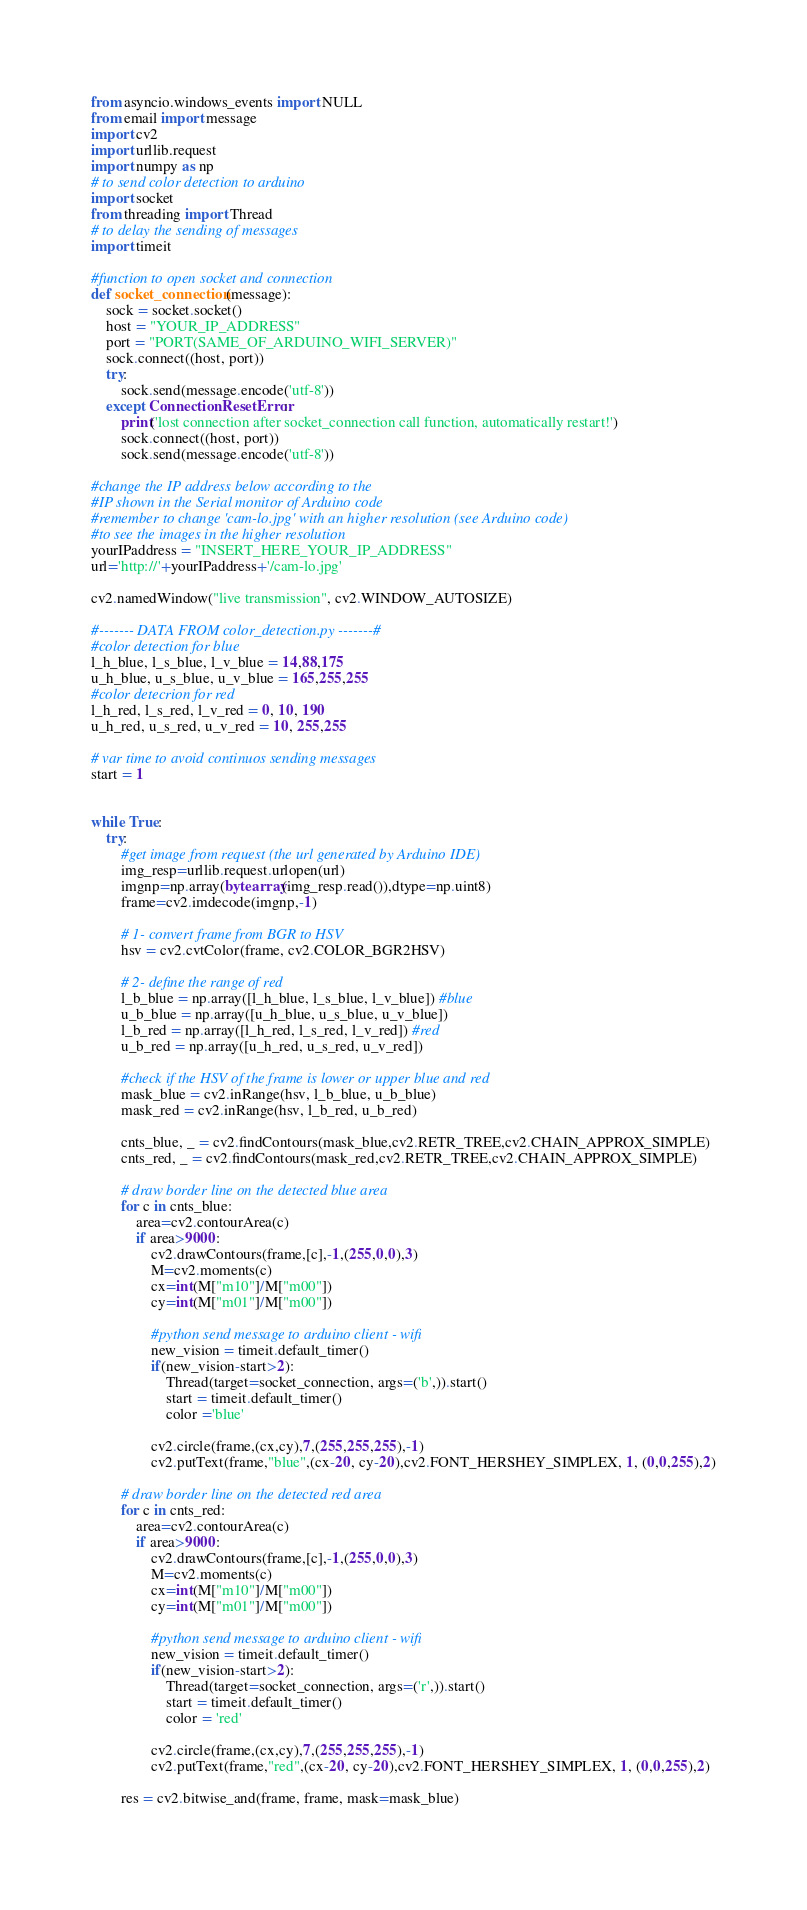<code> <loc_0><loc_0><loc_500><loc_500><_Python_>from asyncio.windows_events import NULL
from email import message
import cv2
import urllib.request
import numpy as np
# to send color detection to arduino
import socket
from threading import Thread
# to delay the sending of messages
import timeit

#function to open socket and connection
def socket_connection(message):
    sock = socket.socket()
    host = "YOUR_IP_ADDRESS" 
    port = "PORT(SAME_OF_ARDUINO_WIFI_SERVER)"                
    sock.connect((host, port))
    try: 
        sock.send(message.encode('utf-8'))
    except ConnectionResetError:
        print('lost connection after socket_connection call function, automatically restart!')
        sock.connect((host, port))
        sock.send(message.encode('utf-8'))
    
#change the IP address below according to the
#IP shown in the Serial monitor of Arduino code
#remember to change 'cam-lo.jpg' with an higher resolution (see Arduino code)
#to see the images in the higher resolution
yourIPaddress = "INSERT_HERE_YOUR_IP_ADDRESS"
url='http://'+yourIPaddress+'/cam-lo.jpg'

cv2.namedWindow("live transmission", cv2.WINDOW_AUTOSIZE)

#------- DATA FROM color_detection.py -------#
#color detection for blue
l_h_blue, l_s_blue, l_v_blue = 14,88,175
u_h_blue, u_s_blue, u_v_blue = 165,255,255
#color detecrion for red 
l_h_red, l_s_red, l_v_red = 0, 10, 190
u_h_red, u_s_red, u_v_red = 10, 255,255

# var time to avoid continuos sending messages 
start = 1


while True:
    try:
        #get image from request (the url generated by Arduino IDE)
        img_resp=urllib.request.urlopen(url)
        imgnp=np.array(bytearray(img_resp.read()),dtype=np.uint8)
        frame=cv2.imdecode(imgnp,-1)
        
        # 1- convert frame from BGR to HSV
        hsv = cv2.cvtColor(frame, cv2.COLOR_BGR2HSV)
        
        # 2- define the range of red
        l_b_blue = np.array([l_h_blue, l_s_blue, l_v_blue]) #blue
        u_b_blue = np.array([u_h_blue, u_s_blue, u_v_blue])
        l_b_red = np.array([l_h_red, l_s_red, l_v_red]) #red
        u_b_red = np.array([u_h_red, u_s_red, u_v_red])

        #check if the HSV of the frame is lower or upper blue and red
        mask_blue = cv2.inRange(hsv, l_b_blue, u_b_blue)
        mask_red = cv2.inRange(hsv, l_b_red, u_b_red)

        cnts_blue, _ = cv2.findContours(mask_blue,cv2.RETR_TREE,cv2.CHAIN_APPROX_SIMPLE)
        cnts_red, _ = cv2.findContours(mask_red,cv2.RETR_TREE,cv2.CHAIN_APPROX_SIMPLE)
    
        # draw border line on the detected blue area
        for c in cnts_blue:
            area=cv2.contourArea(c)
            if area>9000:
                cv2.drawContours(frame,[c],-1,(255,0,0),3)
                M=cv2.moments(c)
                cx=int(M["m10"]/M["m00"])
                cy=int(M["m01"]/M["m00"])

                #python send message to arduino client - wifi
                new_vision = timeit.default_timer()
                if(new_vision-start>2):
                    Thread(target=socket_connection, args=('b',)).start()
                    start = timeit.default_timer()
                    color ='blue'

                cv2.circle(frame,(cx,cy),7,(255,255,255),-1)
                cv2.putText(frame,"blue",(cx-20, cy-20),cv2.FONT_HERSHEY_SIMPLEX, 1, (0,0,255),2)
        
        # draw border line on the detected red area
        for c in cnts_red:
            area=cv2.contourArea(c)
            if area>9000:
                cv2.drawContours(frame,[c],-1,(255,0,0),3)
                M=cv2.moments(c)
                cx=int(M["m10"]/M["m00"])
                cy=int(M["m01"]/M["m00"])

                #python send message to arduino client - wifi
                new_vision = timeit.default_timer()
                if(new_vision-start>2):
                    Thread(target=socket_connection, args=('r',)).start()
                    start = timeit.default_timer()
                    color = 'red'

                cv2.circle(frame,(cx,cy),7,(255,255,255),-1)
                cv2.putText(frame,"red",(cx-20, cy-20),cv2.FONT_HERSHEY_SIMPLEX, 1, (0,0,255),2)
            
        res = cv2.bitwise_and(frame, frame, mask=mask_blue)
    </code> 